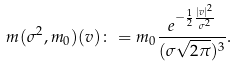<formula> <loc_0><loc_0><loc_500><loc_500>m ( \sigma ^ { 2 } , m _ { 0 } ) ( v ) \colon = m _ { 0 } \frac { e ^ { - \frac { 1 } { 2 } \frac { | v | ^ { 2 } } { \sigma ^ { 2 } } } } { ( \sigma \sqrt { 2 \pi } ) ^ { 3 } } .</formula> 